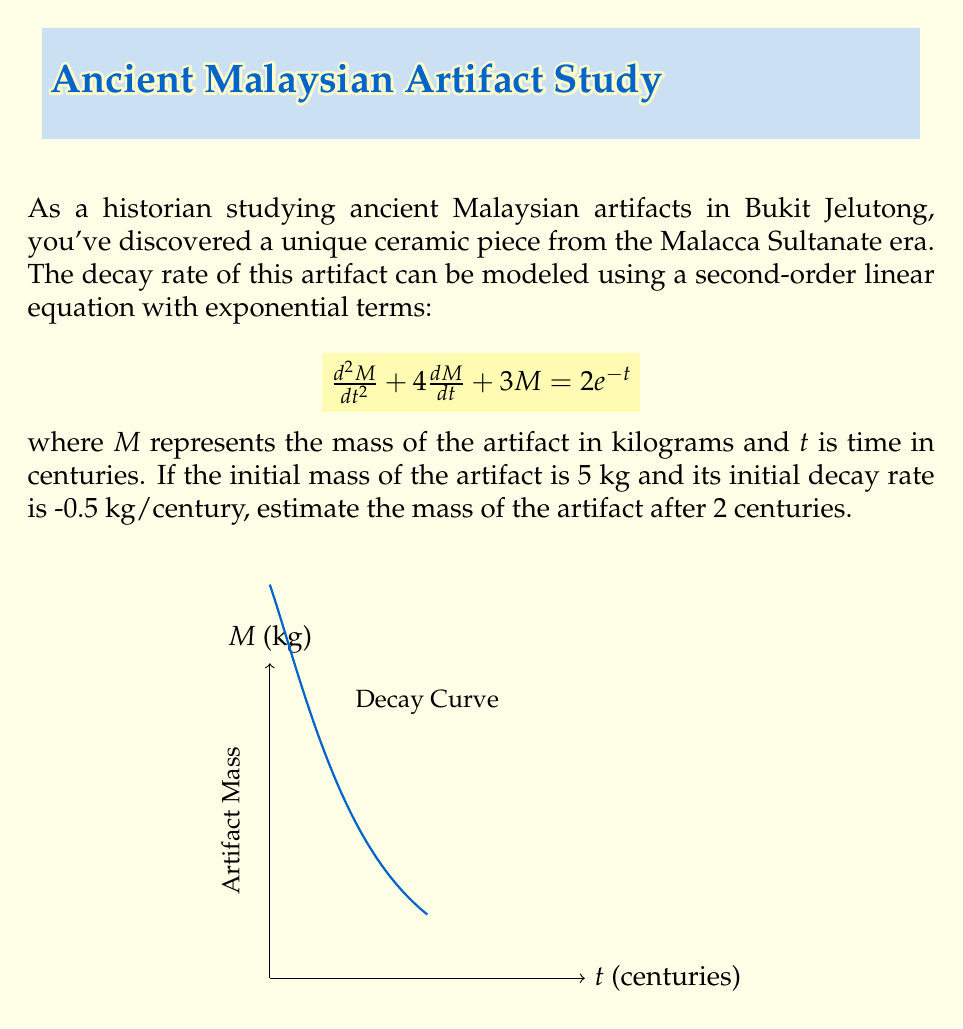Solve this math problem. To solve this problem, we need to follow these steps:

1) The general solution for this type of equation is:
   $$M(t) = c_1e^{-t} + c_2e^{-3t} + e^{-t}$$

2) We need to find $c_1$ and $c_2$ using the initial conditions:
   At $t=0$, $M(0) = 5$ and $\frac{dM}{dt}(0) = -0.5$

3) Using $M(0) = 5$:
   $$5 = c_1 + c_2 + 1$$
   $$c_1 + c_2 = 4 \quad (1)$$

4) Using $\frac{dM}{dt}(0) = -0.5$:
   $$\frac{dM}{dt} = -c_1e^{-t} - 3c_2e^{-3t} - e^{-t}$$
   $$-0.5 = -c_1 - 3c_2 - 1$$
   $$c_1 + 3c_2 = -0.5 \quad (2)$$

5) Solving (1) and (2) simultaneously:
   $c_1 = 5$ and $c_2 = -1$

6) Therefore, the particular solution is:
   $$M(t) = 5e^{-t} - e^{-3t} + e^{-t} = 6e^{-t} - e^{-3t}$$

7) To find $M(2)$, we substitute $t=2$:
   $$M(2) = 6e^{-2} - e^{-6}$$
   $$M(2) = 6(0.1353) - 0.0025 = 0.8093$$

Therefore, after 2 centuries, the estimated mass of the artifact is approximately 0.8093 kg.
Answer: 0.8093 kg 